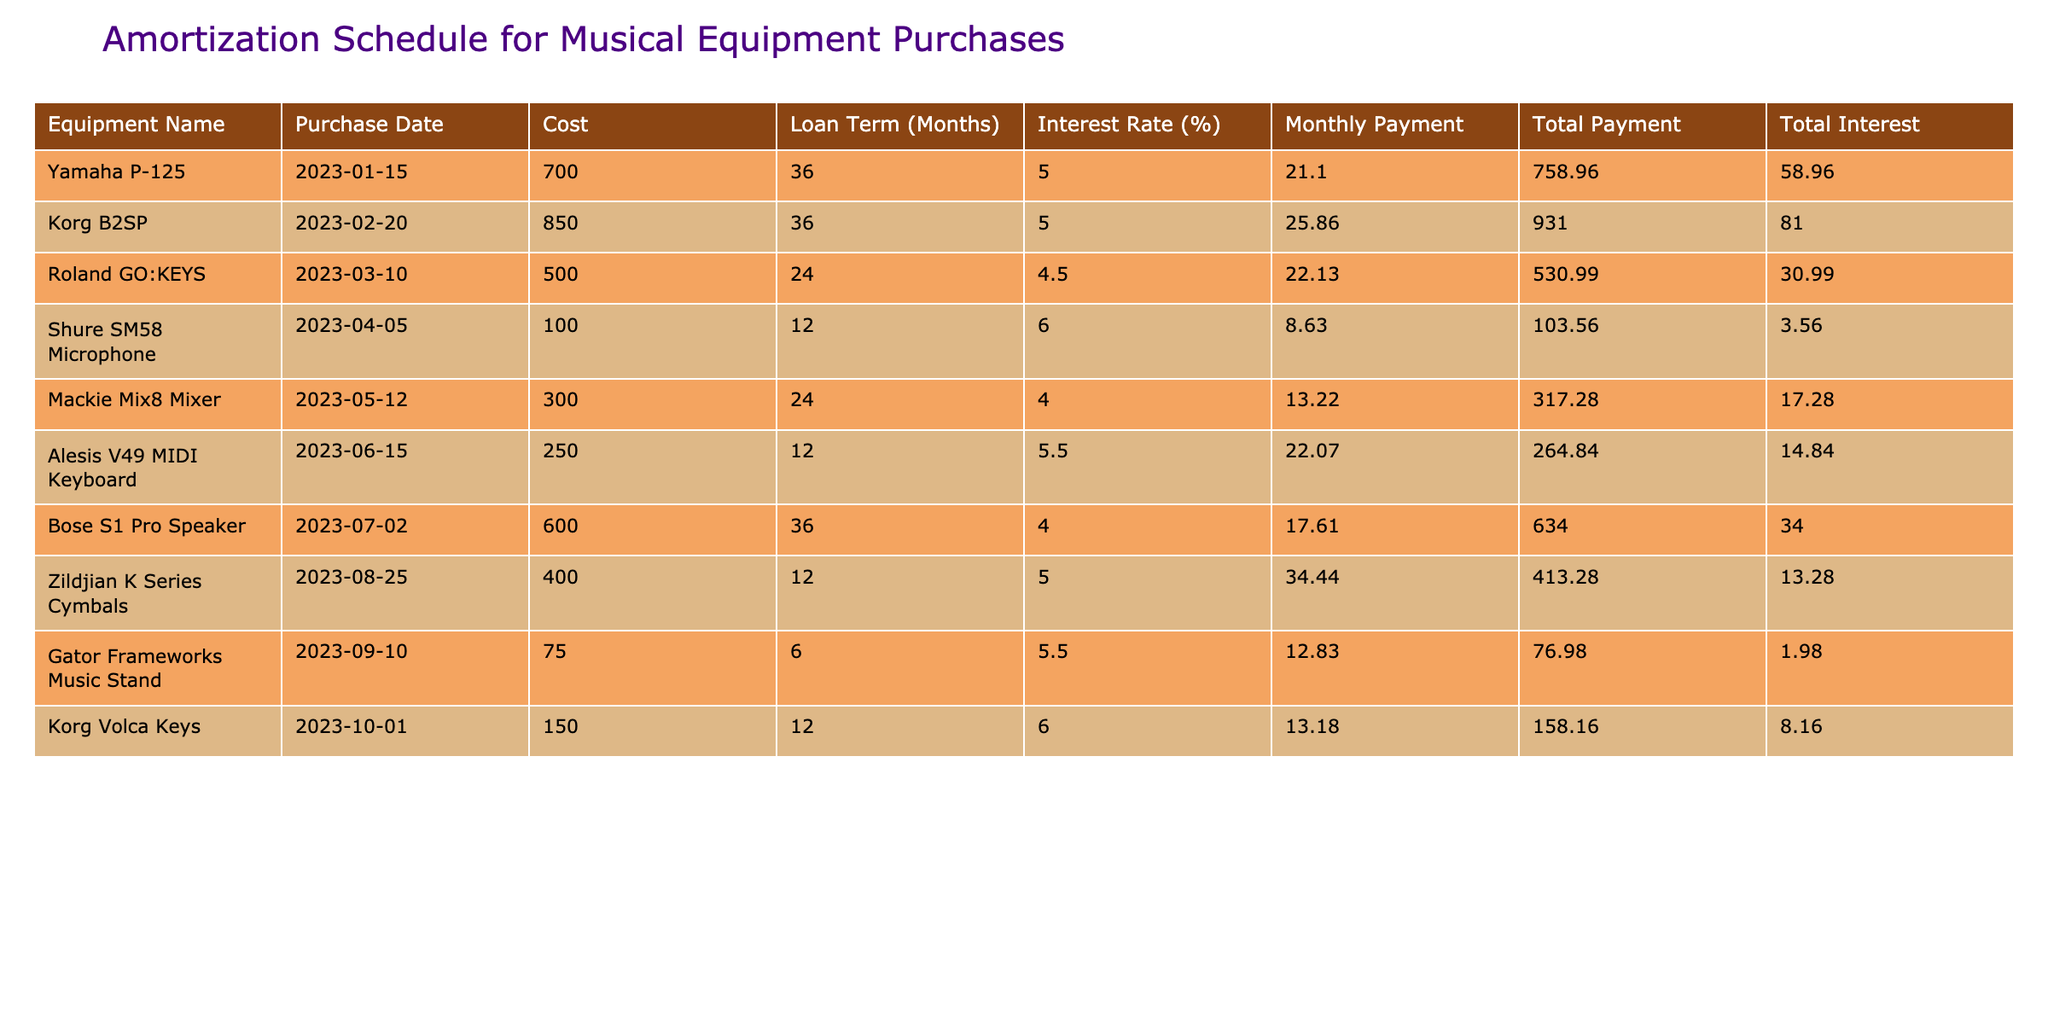What is the total cost of the Yamaha P-125? The total cost of the Yamaha P-125 is directly listed in the table under "Total Payment." It states 758.96.
Answer: 758.96 What is the monthly payment for the Korg B2SP? The table specifies the monthly payment for the Korg B2SP in the "Monthly Payment" column, which is 25.86.
Answer: 25.86 How much total interest will be paid on the Shure SM58 Microphone? The total interest for the Shure SM58 Microphone is found in the "Total Interest" column, which shows 3.56.
Answer: 3.56 Which equipment has the highest total payment? By comparing the "Total Payment" values, the Korg B2SP has the highest total payment of 931.00, which is greater than any other equipment.
Answer: Korg B2SP What is the average monthly payment across all equipment? First, we sum the monthly payments: (21.10 + 25.86 + 22.13 + 8.63 + 13.22 + 22.07 + 17.61 + 34.44 + 12.83 + 13.18) =  177.41. Then, divide by the number of items (10), resulting in an average monthly payment of 177.41 / 10 = 17.74.
Answer: 17.74 Is the total interest for the Mackie Mix8 Mixer more than 15? By looking at the "Total Interest" for the Mackie Mix8 Mixer, which is 17.28, we can confirm it is greater than 15, thus the answer is yes.
Answer: Yes What is the difference in total payment between the Roland GO:KEYS and the Zildjian K Series Cymbals? The total payment for Roland GO:KEYS is 530.99 and for Zildjian K Series Cymbals, it is 413.28. The difference is calculated as 530.99 - 413.28 = 117.71.
Answer: 117.71 Which piece of equipment was purchased first in 2023? Checking the "Purchase Date" column, the Yamaha P-125 is the first one listed, with the date of 2023-01-15.
Answer: Yamaha P-125 How much total interest will be paid for the equipment with the shortest loan term? The equipment with the shortest loan term is the Gator Frameworks Music Stand, which has a total interest of 1.98 as indicated in the "Total Interest" column.
Answer: 1.98 What is the total cost of all equipment combined? We add up all the total payments: 758.96 + 931.00 + 530.99 + 103.56 + 317.28 + 264.84 + 634.00 + 413.28 + 76.98 + 158.16 = 3,829.05.
Answer: 3,829.05 